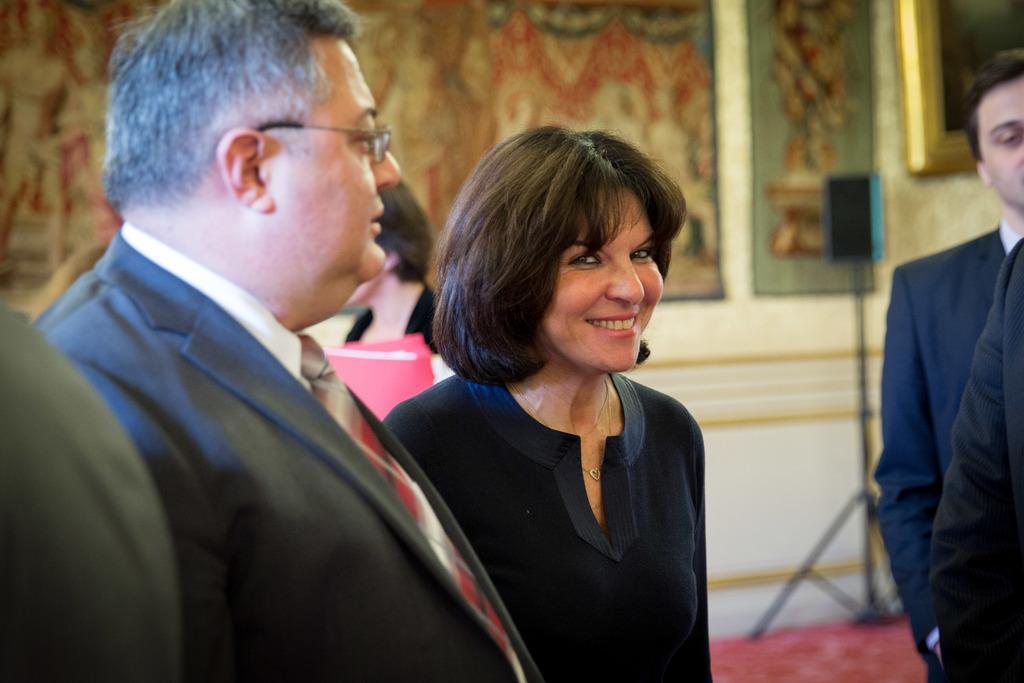Could you give a brief overview of what you see in this image? In the picture we can see a man and a woman standing, a man is wearing a blazer, tie and shirt and woman is smiling and wearing a blue dress and in the background we can see a speaker on the stand and some paintings to the wall. 